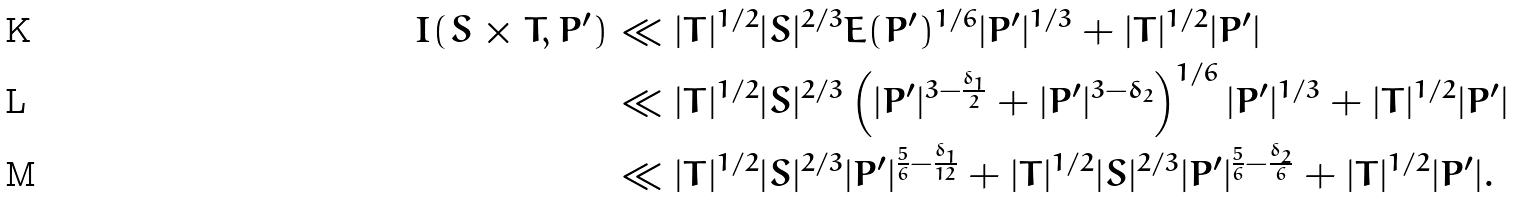<formula> <loc_0><loc_0><loc_500><loc_500>I ( S \times T , P ^ { \prime } ) & \ll | T | ^ { 1 / 2 } | S | ^ { 2 / 3 } E ( P ^ { \prime } ) ^ { 1 / 6 } | P ^ { \prime } | ^ { 1 / 3 } + | T | ^ { 1 / 2 } | P ^ { \prime } | \\ & \ll | T | ^ { 1 / 2 } | S | ^ { 2 / 3 } \left ( | P ^ { \prime } | ^ { 3 - \frac { \delta _ { 1 } } { 2 } } + | P ^ { \prime } | ^ { 3 - \delta _ { 2 } } \right ) ^ { 1 / 6 } | P ^ { \prime } | ^ { 1 / 3 } + | T | ^ { 1 / 2 } | P ^ { \prime } | \\ & \ll | T | ^ { 1 / 2 } | S | ^ { 2 / 3 } | P ^ { \prime } | ^ { \frac { 5 } { 6 } - \frac { \delta _ { 1 } } { 1 2 } } + | T | ^ { 1 / 2 } | S | ^ { 2 / 3 } | P ^ { \prime } | ^ { \frac { 5 } { 6 } - \frac { \delta _ { 2 } } { 6 } } + | T | ^ { 1 / 2 } | P ^ { \prime } | .</formula> 